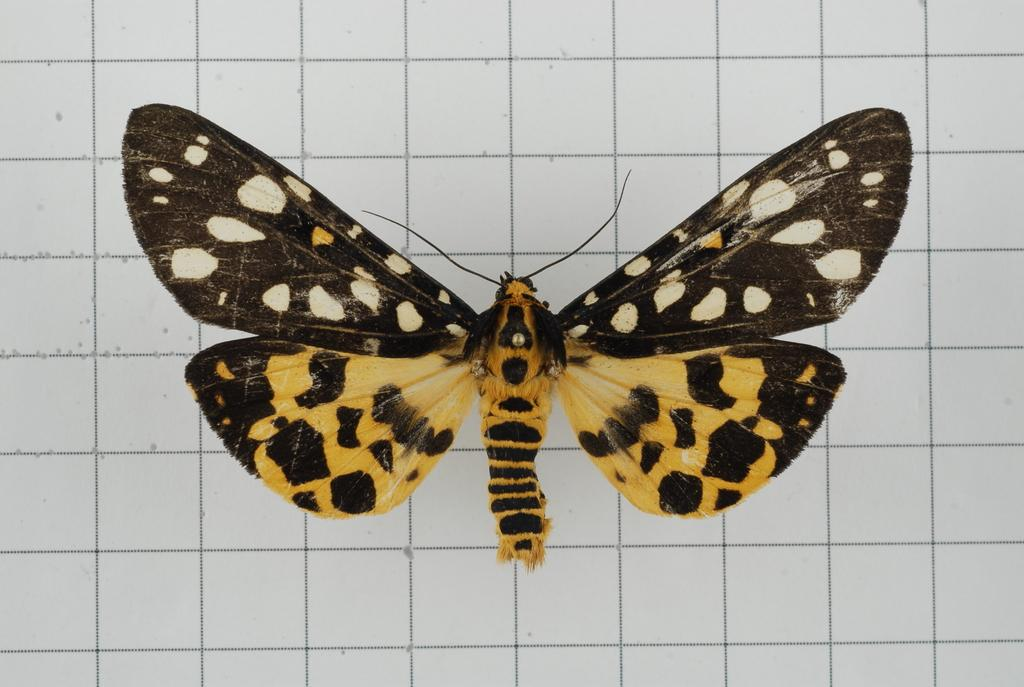What is the main subject of the image? There is a butterfly in the image. Where is the butterfly located? The butterfly is on a white object. What type of surface is the white object? The white object appears to be a wall. How many ladybugs are present on the wall in the image? There are no ladybugs present in the image; only a butterfly is visible on the wall. What wish does the butterfly grant to the viewer in the image? The image does not depict the butterfly granting any wishes to the viewer. 